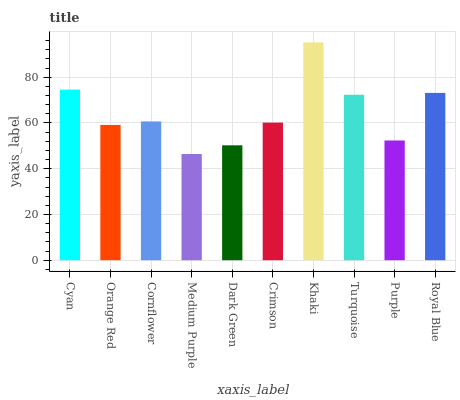Is Orange Red the minimum?
Answer yes or no. No. Is Orange Red the maximum?
Answer yes or no. No. Is Cyan greater than Orange Red?
Answer yes or no. Yes. Is Orange Red less than Cyan?
Answer yes or no. Yes. Is Orange Red greater than Cyan?
Answer yes or no. No. Is Cyan less than Orange Red?
Answer yes or no. No. Is Cornflower the high median?
Answer yes or no. Yes. Is Crimson the low median?
Answer yes or no. Yes. Is Purple the high median?
Answer yes or no. No. Is Dark Green the low median?
Answer yes or no. No. 